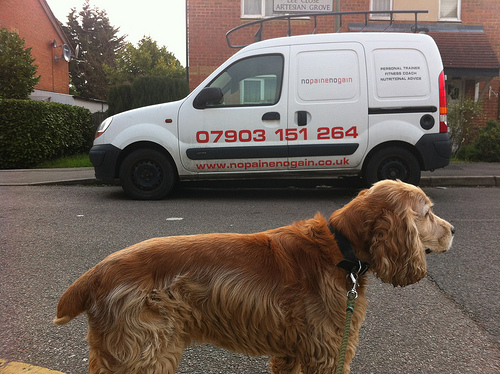<image>
Is the car next to the dog? Yes. The car is positioned adjacent to the dog, located nearby in the same general area. 